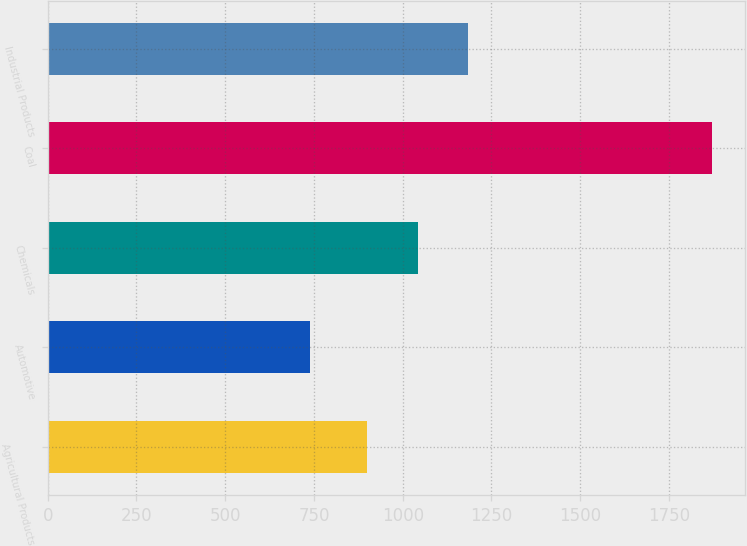Convert chart. <chart><loc_0><loc_0><loc_500><loc_500><bar_chart><fcel>Agricultural Products<fcel>Automotive<fcel>Chemicals<fcel>Coal<fcel>Industrial Products<nl><fcel>900<fcel>738<fcel>1042<fcel>1871<fcel>1185<nl></chart> 